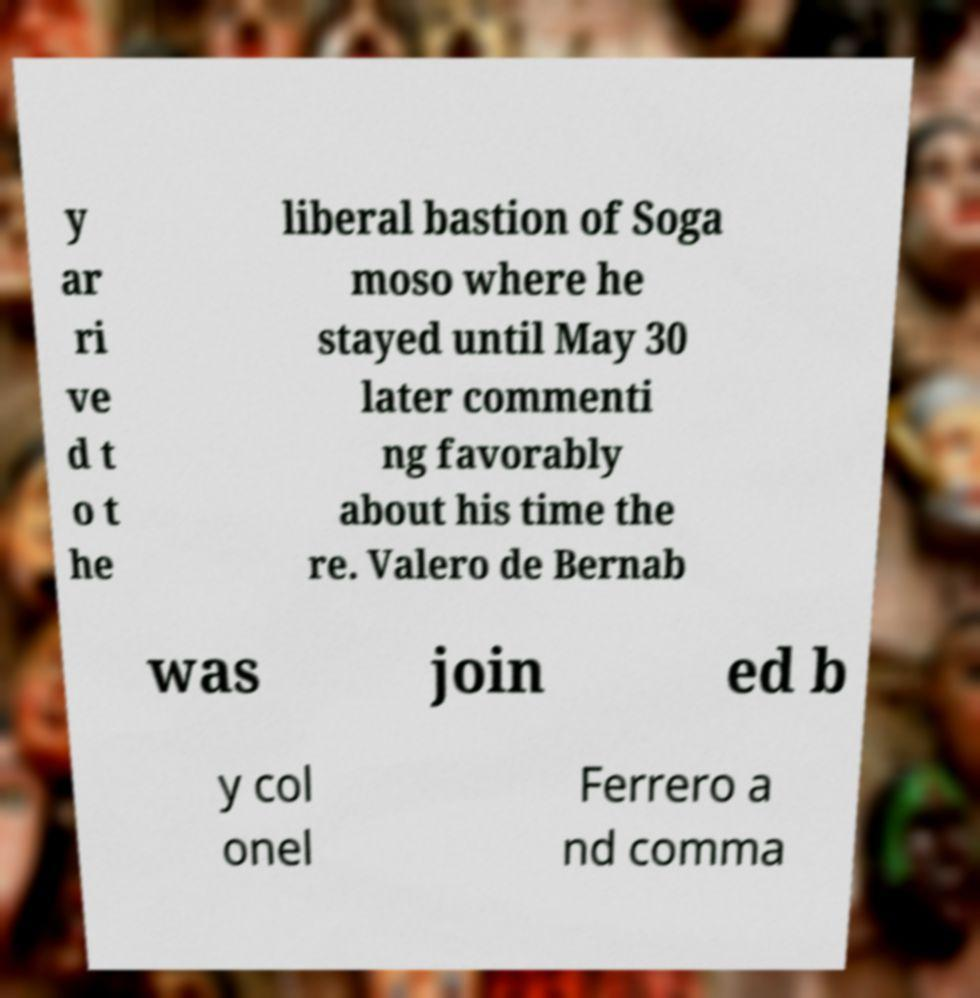For documentation purposes, I need the text within this image transcribed. Could you provide that? y ar ri ve d t o t he liberal bastion of Soga moso where he stayed until May 30 later commenti ng favorably about his time the re. Valero de Bernab was join ed b y col onel Ferrero a nd comma 